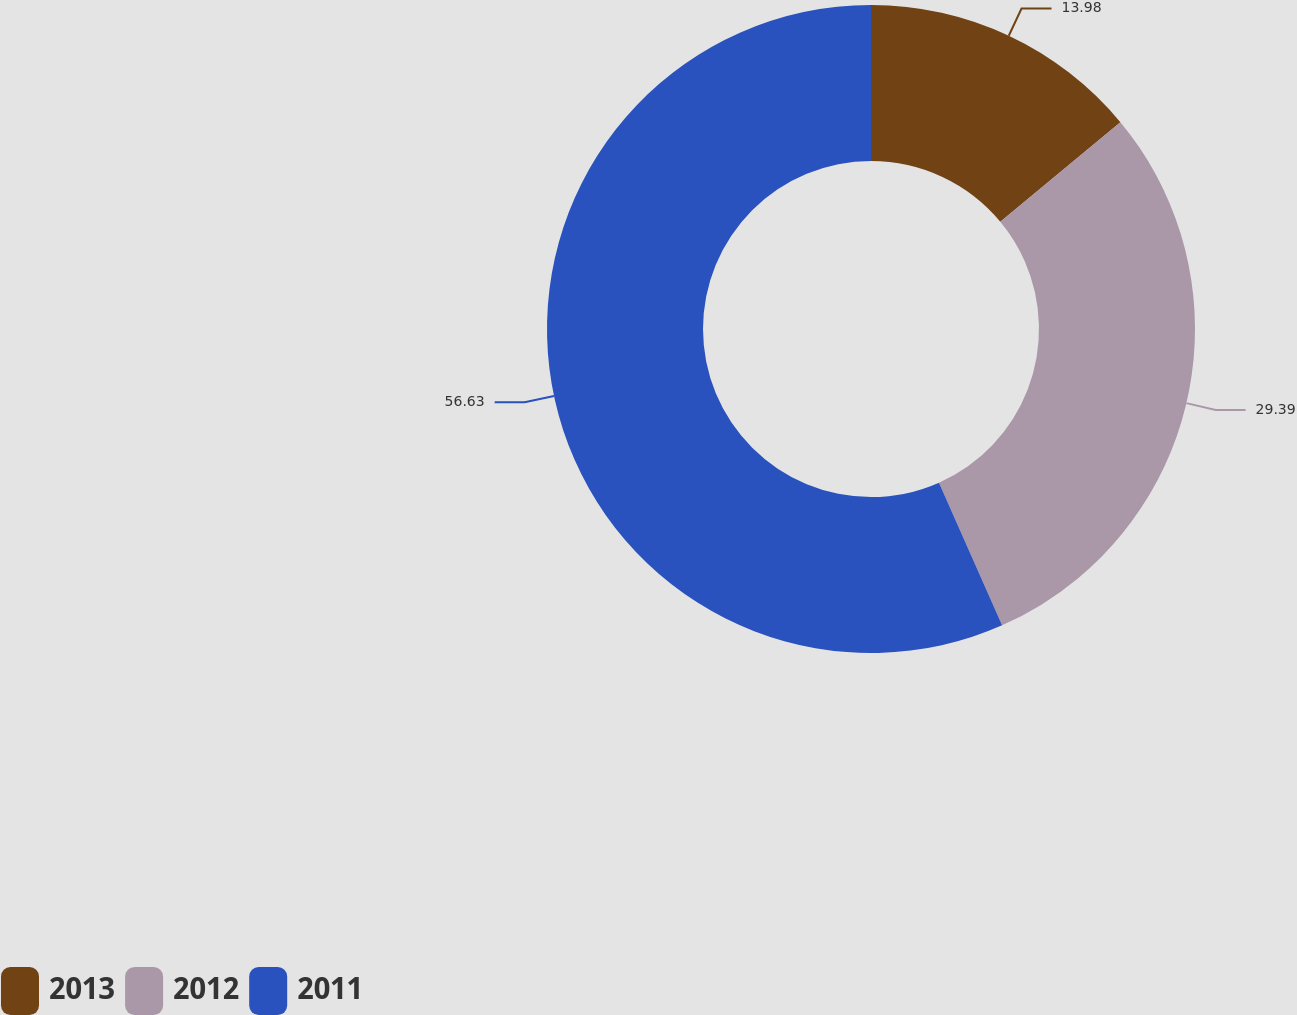<chart> <loc_0><loc_0><loc_500><loc_500><pie_chart><fcel>2013<fcel>2012<fcel>2011<nl><fcel>13.98%<fcel>29.39%<fcel>56.63%<nl></chart> 